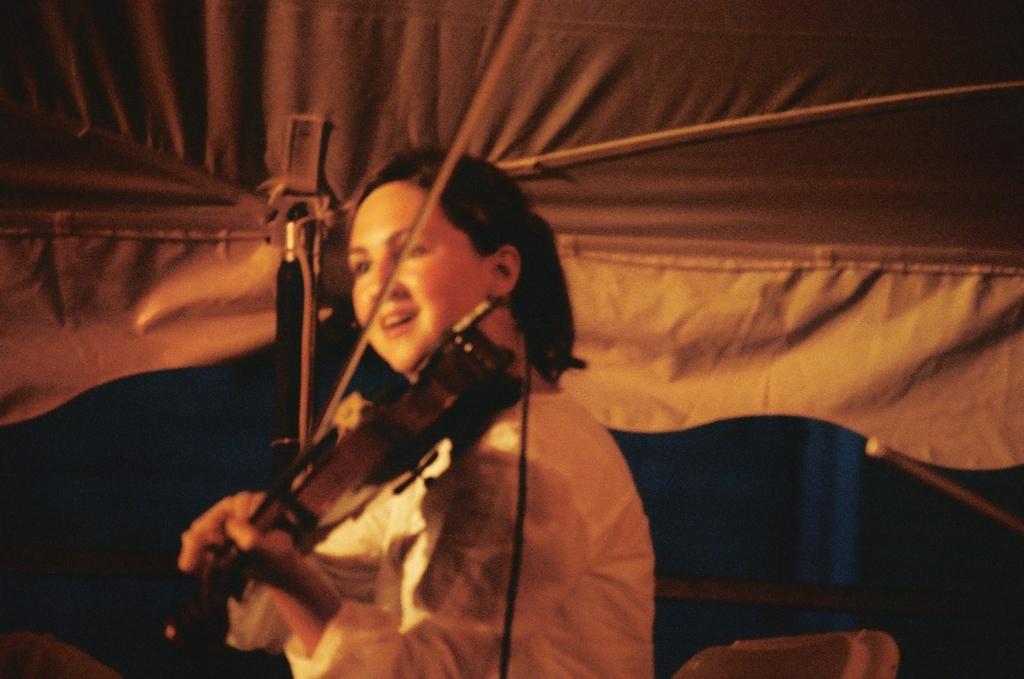Could you give a brief overview of what you see in this image? This is the woman standing and playing violin. This is the cloth at the top. I think this is tent. Background looks dark. 